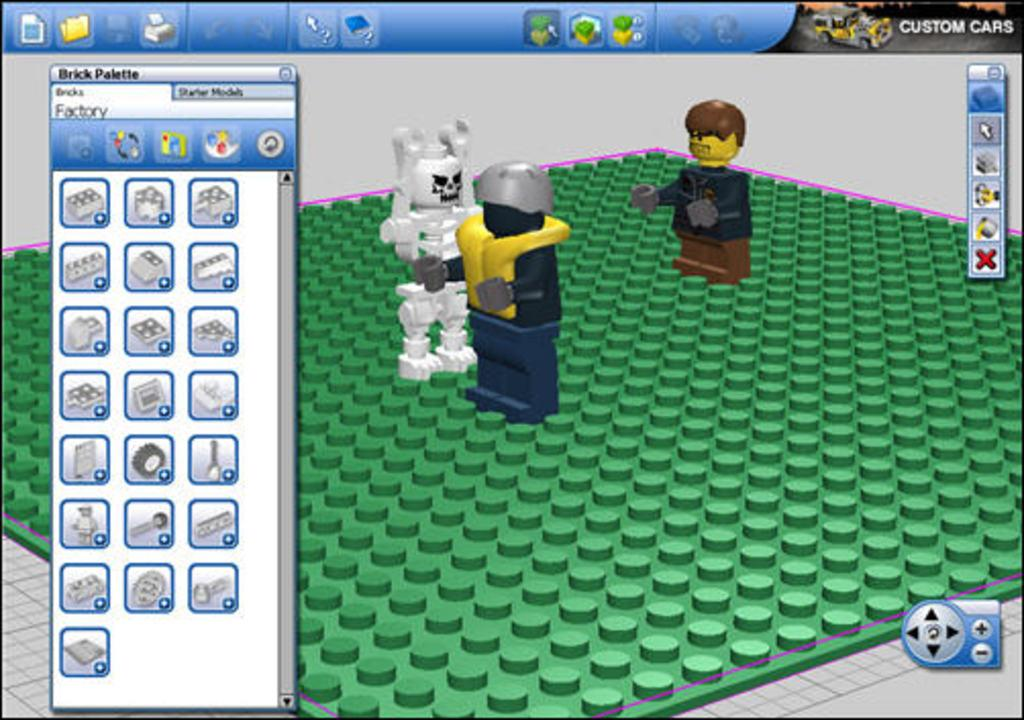<image>
Share a concise interpretation of the image provided. a video game screen with Custom Cars option on top right corner 